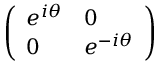<formula> <loc_0><loc_0><loc_500><loc_500>\left ( \begin{array} { l l } { e ^ { i \theta } } & { 0 } \\ { 0 } & { e ^ { - i \theta } } \end{array} \right )</formula> 